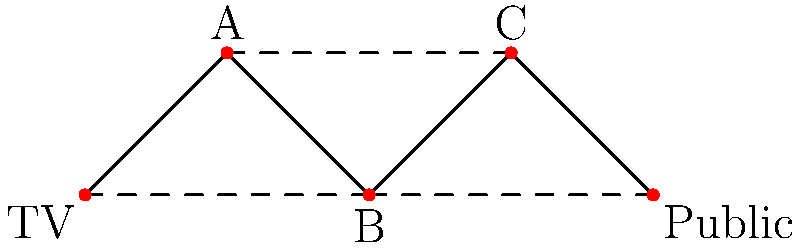Given the network topology representing information flow from TV broadcasts to public sentiment during the Cold War, what is the minimum number of edges that need to be removed to disconnect the "TV" node from the "Public" node? To solve this problem, we need to analyze the paths between the "TV" node and the "Public" node:

1. First, identify all possible paths from "TV" to "Public":
   Path 1: TV -> A -> B -> C -> Public
   Path 2: TV -> A -> C -> Public
   Path 3: TV -> B -> C -> Public
   Path 4: TV -> B -> Public

2. Notice that all paths go through node B, making it a critical point in the network.

3. The concept we're dealing with here is the minimum cut set, which is the smallest set of edges whose removal disconnects the source (TV) from the sink (Public).

4. In this case, we have two options for the minimum cut:
   Option 1: Remove the edge TV -> B and B -> Public
   Option 2: Remove the single edge B -> C and B -> Public

5. The second option requires removing fewer edges (2) compared to the first option (2).

Therefore, the minimum number of edges that need to be removed to disconnect "TV" from "Public" is 2.
Answer: 2 